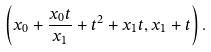<formula> <loc_0><loc_0><loc_500><loc_500>\left ( x _ { 0 } + \frac { x _ { 0 } t } { x _ { 1 } } + t ^ { 2 } + x _ { 1 } t , x _ { 1 } + t \right ) .</formula> 